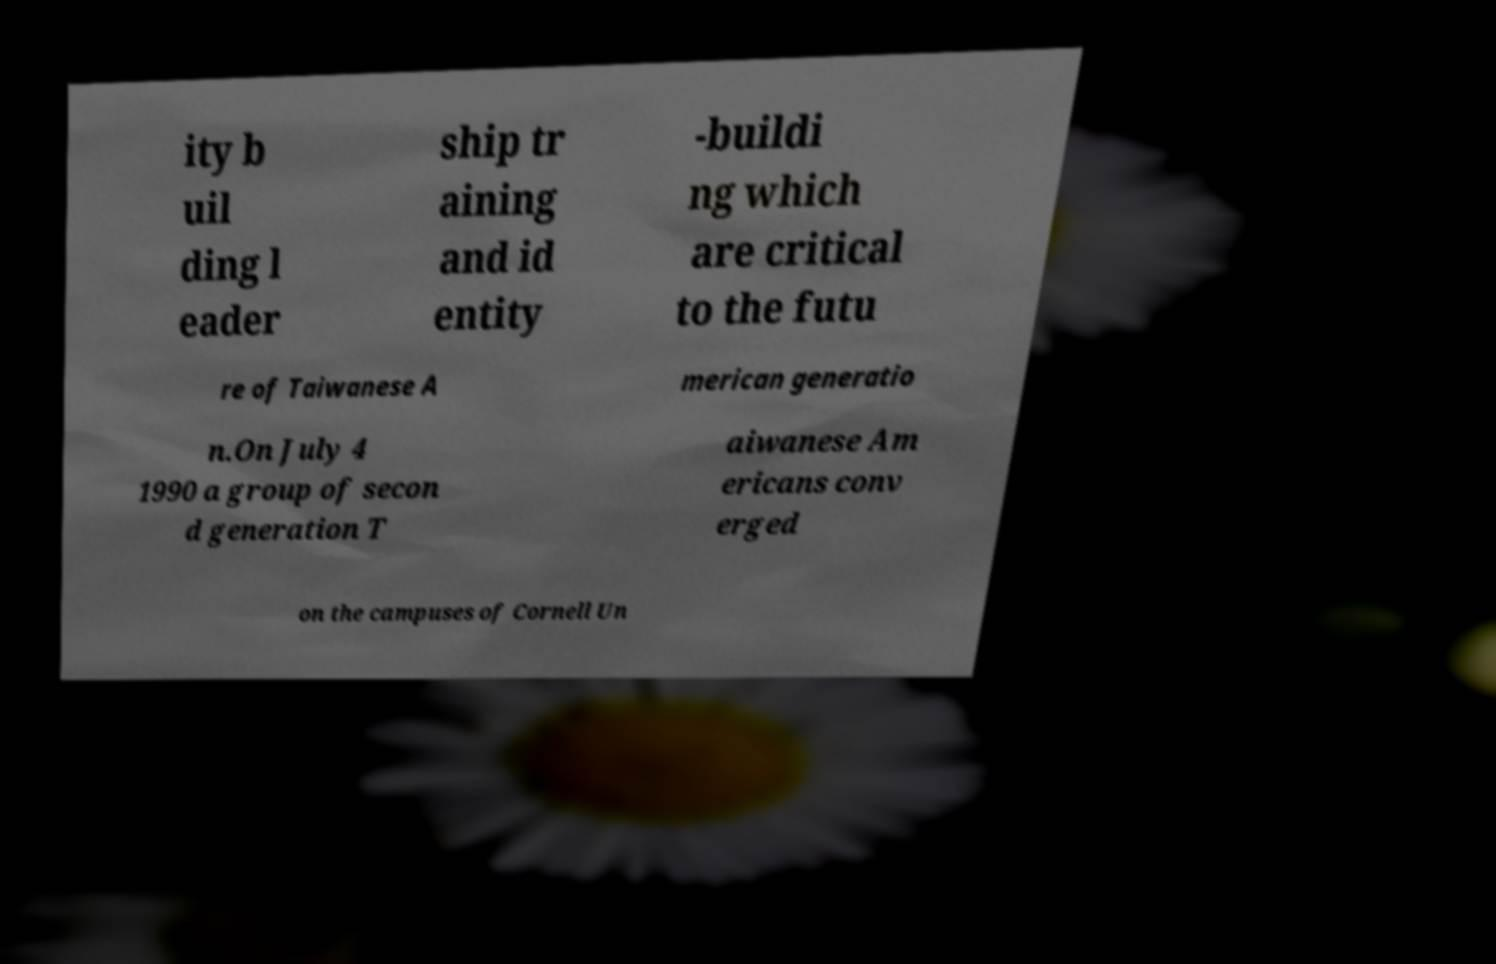I need the written content from this picture converted into text. Can you do that? ity b uil ding l eader ship tr aining and id entity -buildi ng which are critical to the futu re of Taiwanese A merican generatio n.On July 4 1990 a group of secon d generation T aiwanese Am ericans conv erged on the campuses of Cornell Un 